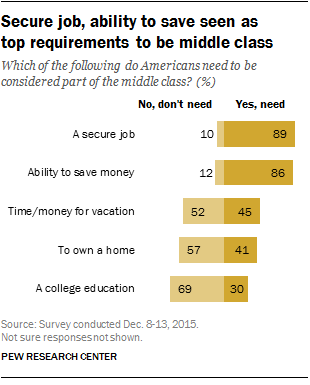List a handful of essential elements in this visual. A recent survey has revealed that 89% of people require a secure job to maintain their standard of living. According to the survey, out of all the requirements, approximately 2% of the respondents indicated that over 50% of people need them. 